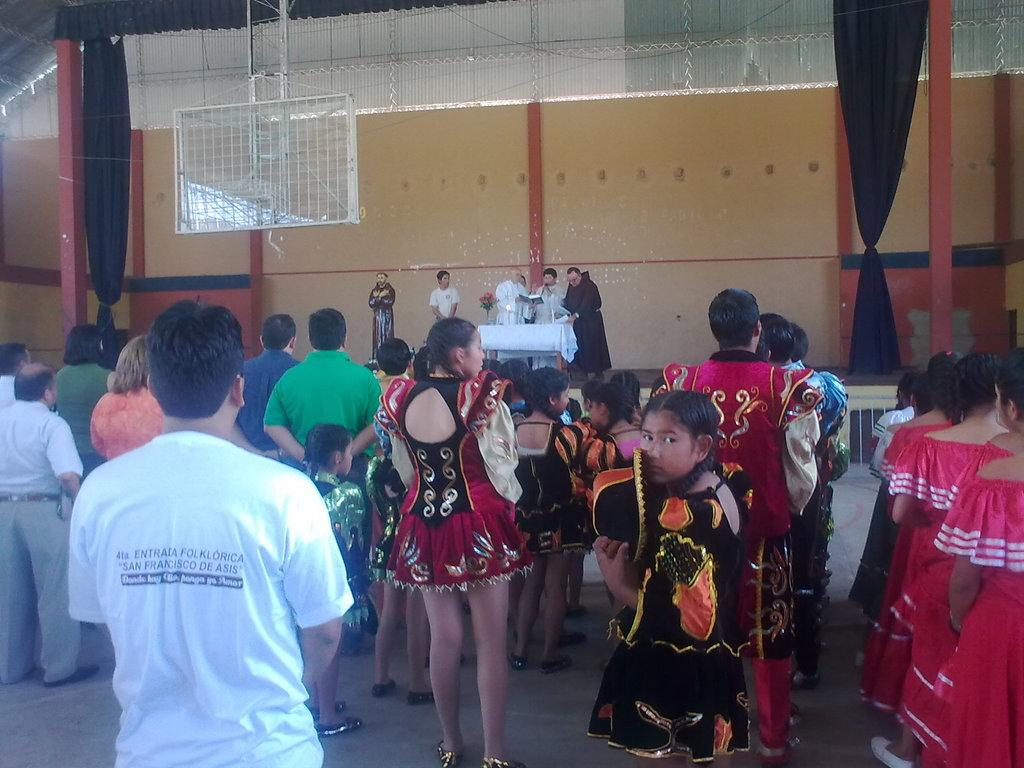How many people are in the image? There is a group of people standing in the image. What is the surface on which the people are standing? The people are standing on the floor. What can be seen in the background of the image? There is a wall in the image. What furniture is present in the image? There is a table in the image. What decorative items are on the table? The table has flowers on it. What is covering the table? A white cloth is covering the table. How does the car measure the distance between the people in the image? There is no car present in the image, so it cannot measure the distance between the people. 